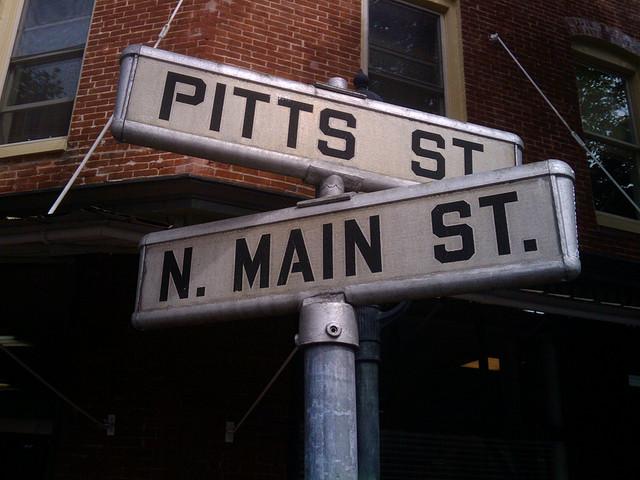What is the building made of?
Short answer required. Brick. What is the first letter of the top sign?
Concise answer only. P. What does the sign say?
Keep it brief. Pitts st n main st. Is it night time?
Quick response, please. No. What color are the sign letters?
Be succinct. Black. Can you go in both directions on this street?
Concise answer only. Yes. 